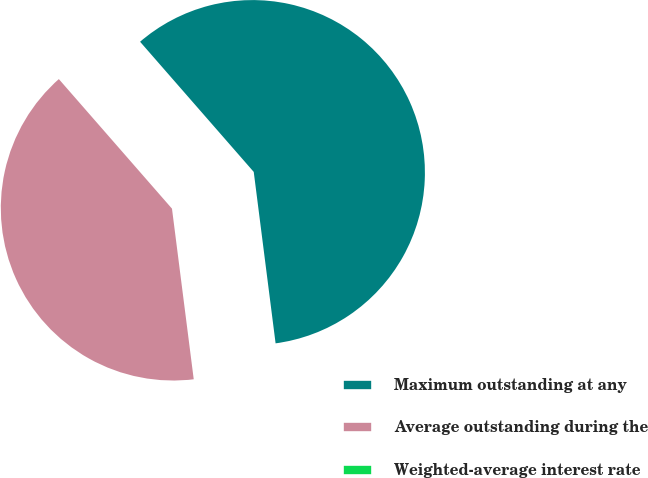Convert chart to OTSL. <chart><loc_0><loc_0><loc_500><loc_500><pie_chart><fcel>Maximum outstanding at any<fcel>Average outstanding during the<fcel>Weighted-average interest rate<nl><fcel>59.4%<fcel>40.59%<fcel>0.0%<nl></chart> 